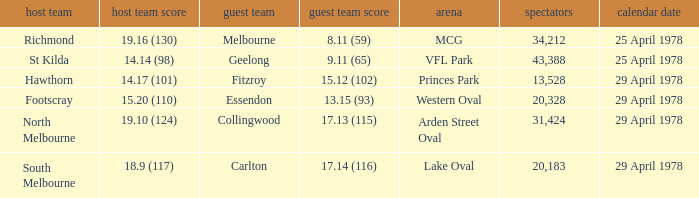Who was the home team at MCG? Richmond. 